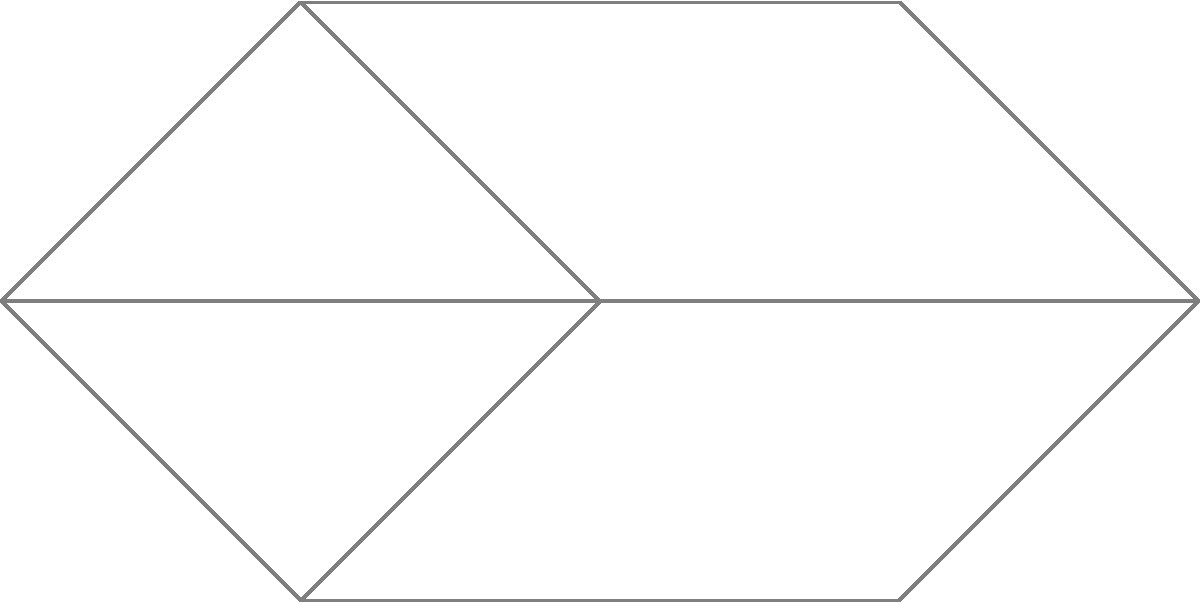In this topological representation of soul music's geographic spread, each vertex represents a major city, and each region represents a distinct style or subgenre. If we want to color the map so that no adjacent regions have the same color, what is the minimum number of colors needed according to the Four Color Theorem, and how does this relate to the maximum degree of any vertex in the graph? To answer this question, we need to follow these steps:

1. Understand the Four Color Theorem:
   The Four Color Theorem states that any map in a plane can be colored using at most four colors, such that no adjacent regions share the same color.

2. Analyze the given graph:
   - The graph represents cities (vertices) and connections between them (edges).
   - Regions formed by these connections represent different soul music subgenres or styles.

3. Consider the maximum degree of vertices:
   - The degree of a vertex is the number of edges connected to it.
   - In this graph, vertex 3 has the highest degree with 4 connections.

4. Relate the maximum degree to chromatic number:
   - The chromatic number (minimum number of colors needed) is always less than or equal to the maximum degree plus one.
   - In this case: Chromatic number ≤ (Maximum degree + 1) = 4 + 1 = 5

5. Apply the Four Color Theorem:
   - Despite the upper bound of 5 from the degree analysis, the Four Color Theorem guarantees that 4 colors are sufficient.

6. Interpret the result:
   - The minimum number of colors needed is 4.
   - This corresponds to the maximum number of distinct soul music subgenres that can be adjacent to each other without overlap.

Therefore, the minimum number of colors needed is 4, which is equal to the maximum degree of any vertex in the graph.
Answer: 4 colors; equal to max vertex degree 